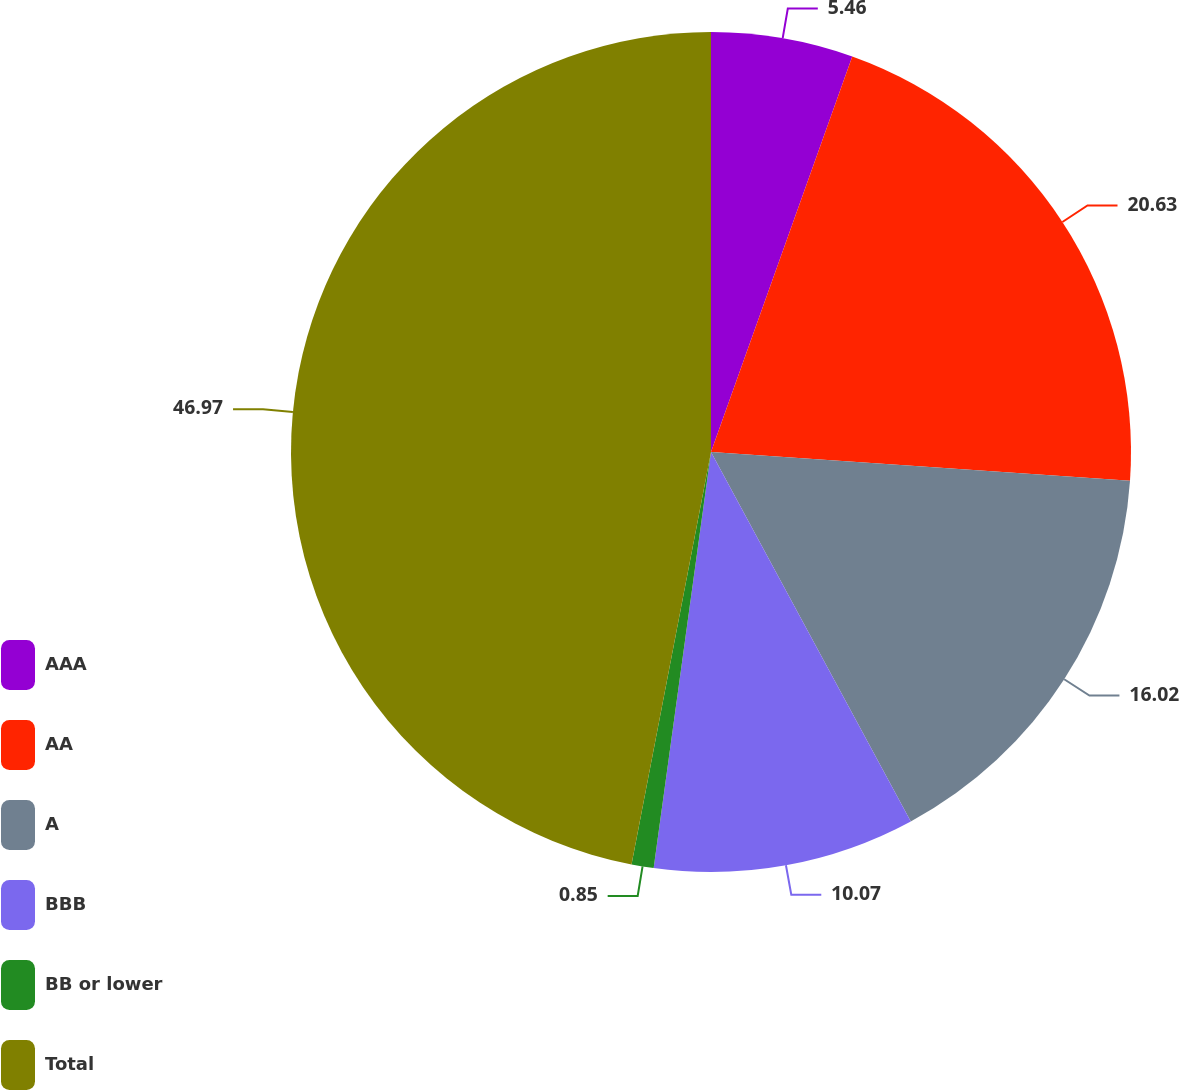Convert chart to OTSL. <chart><loc_0><loc_0><loc_500><loc_500><pie_chart><fcel>AAA<fcel>AA<fcel>A<fcel>BBB<fcel>BB or lower<fcel>Total<nl><fcel>5.46%<fcel>20.63%<fcel>16.02%<fcel>10.07%<fcel>0.85%<fcel>46.97%<nl></chart> 